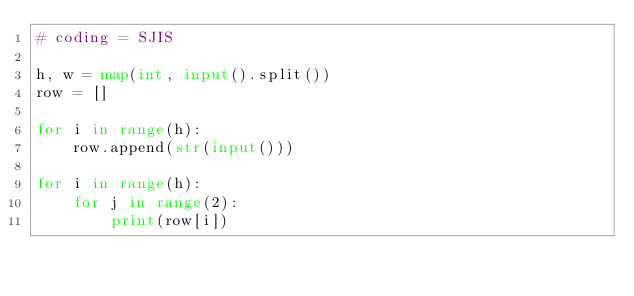Convert code to text. <code><loc_0><loc_0><loc_500><loc_500><_Python_># coding = SJIS

h, w = map(int, input().split())
row = []

for i in range(h):
    row.append(str(input()))

for i in range(h):
    for j in range(2):
        print(row[i])
</code> 